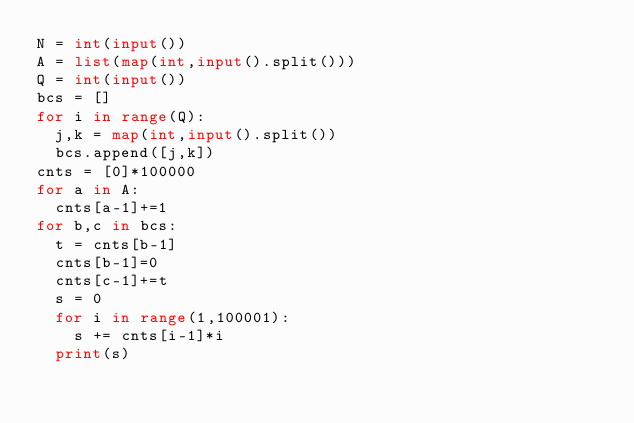Convert code to text. <code><loc_0><loc_0><loc_500><loc_500><_Python_>N = int(input())
A = list(map(int,input().split()))
Q = int(input())
bcs = []
for i in range(Q):
  j,k = map(int,input().split())
  bcs.append([j,k])
cnts = [0]*100000
for a in A:
  cnts[a-1]+=1
for b,c in bcs:
  t = cnts[b-1]
  cnts[b-1]=0
  cnts[c-1]+=t
  s = 0
  for i in range(1,100001):
    s += cnts[i-1]*i
  print(s)</code> 